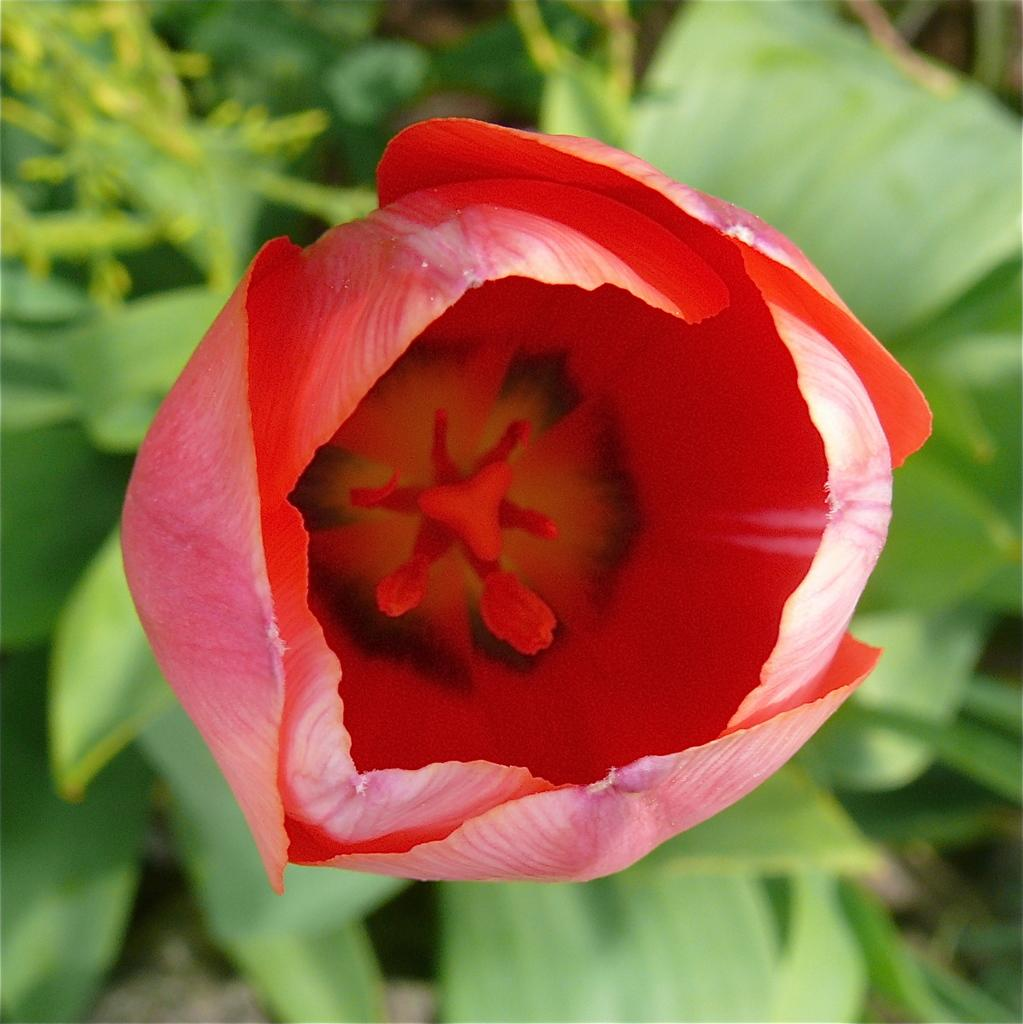What type of flower is present in the image? There is a red color flower in the image. What color are the leaves visible in the image? The leaves in the image are green. How many pests can be seen crawling on the flower in the image? There are no pests visible in the image; it only features a red flower and green leaves. 